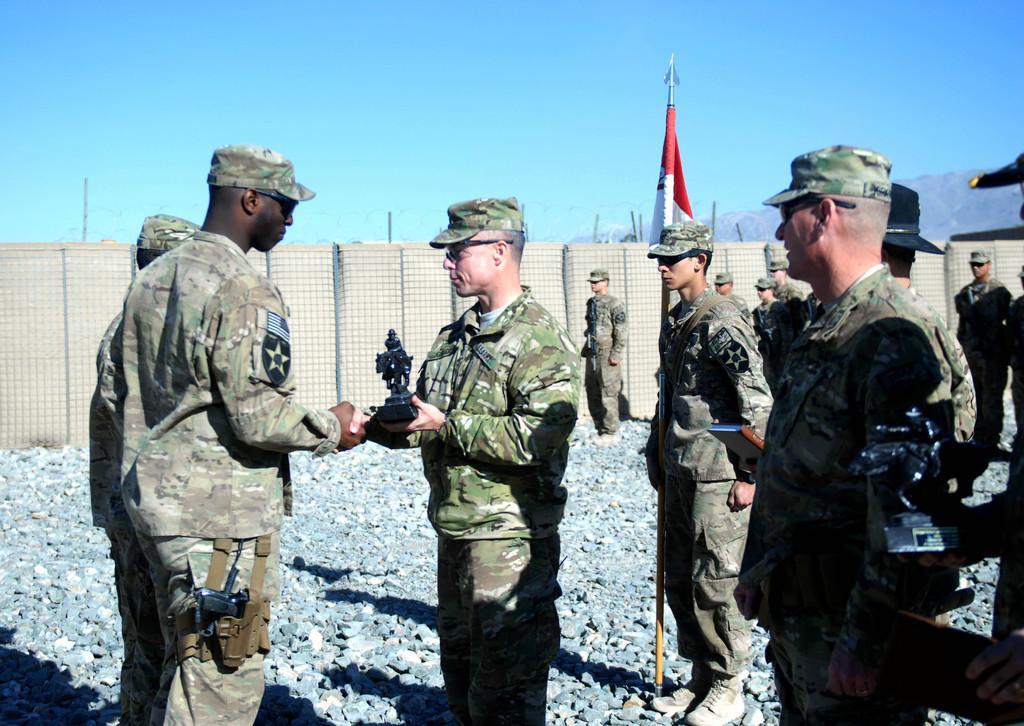How would you summarize this image in a sentence or two? In this image we can see many people wearing caps and goggles. One person is holding something in the hand. Another person is holding a flag. On the ground there are stones. In the back there is a fencing, sky and hill. 